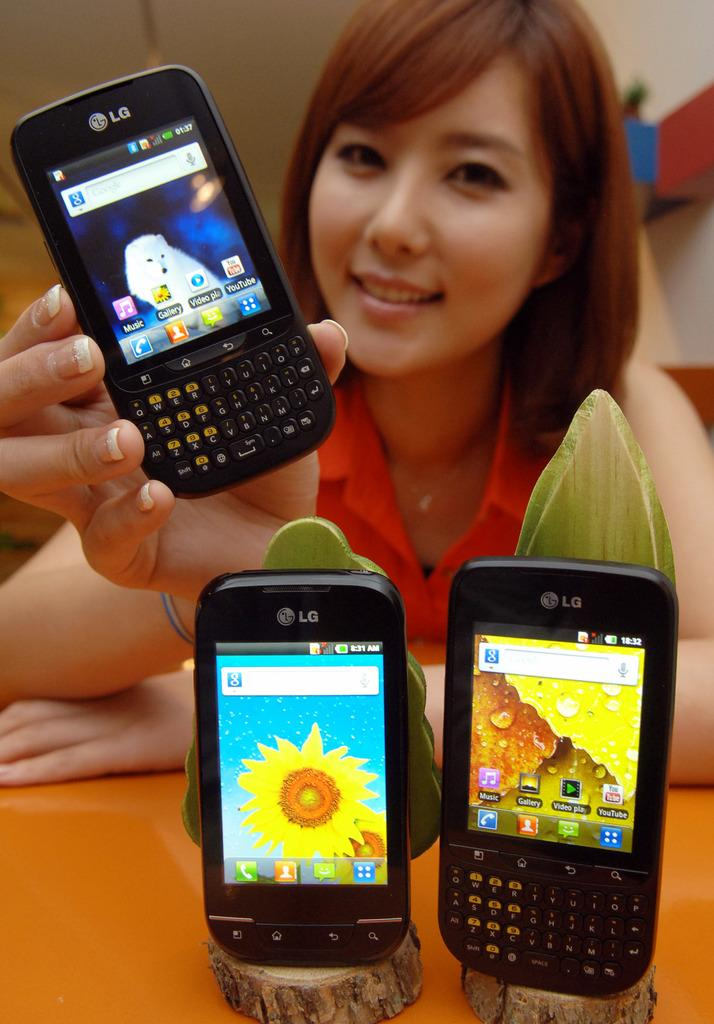<image>
Write a terse but informative summary of the picture. Woman holding an LG cellphone with the Music app as the first app. 